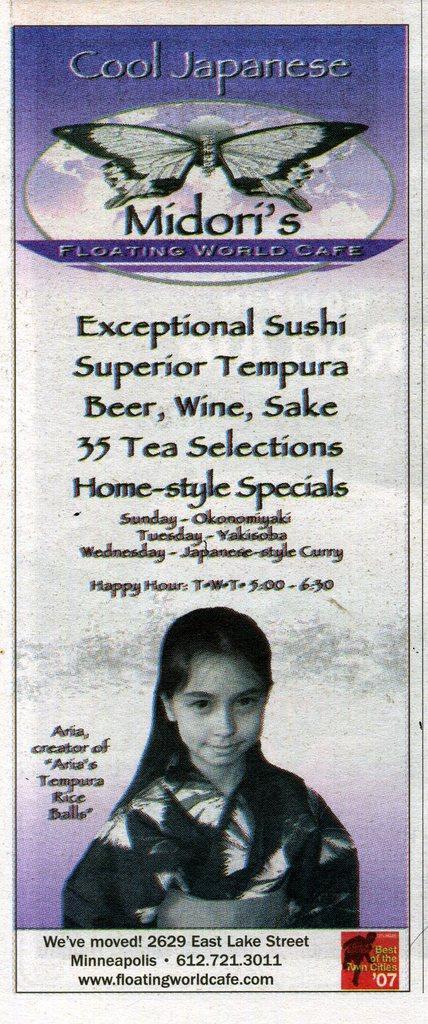Could you give a brief overview of what you see in this image? In this image, we can see a poster with some images and text. 